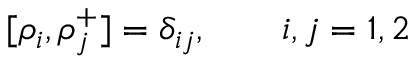<formula> <loc_0><loc_0><loc_500><loc_500>[ \rho _ { i } , \rho _ { j } ^ { + } ] = \delta _ { i j } , \quad i , j = 1 , 2</formula> 